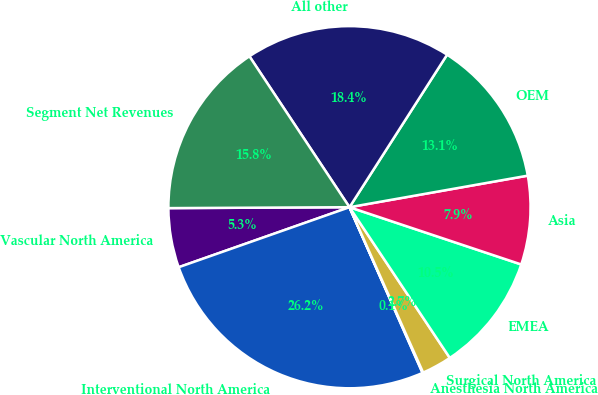Convert chart. <chart><loc_0><loc_0><loc_500><loc_500><pie_chart><fcel>Vascular North America<fcel>Interventional North America<fcel>Anesthesia North America<fcel>Surgical North America<fcel>EMEA<fcel>Asia<fcel>OEM<fcel>All other<fcel>Segment Net Revenues<nl><fcel>5.3%<fcel>26.23%<fcel>0.06%<fcel>2.68%<fcel>10.53%<fcel>7.91%<fcel>13.15%<fcel>18.38%<fcel>15.76%<nl></chart> 